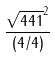<formula> <loc_0><loc_0><loc_500><loc_500>\frac { \sqrt { 4 4 1 } ^ { 2 } } { ( 4 / 4 ) }</formula> 